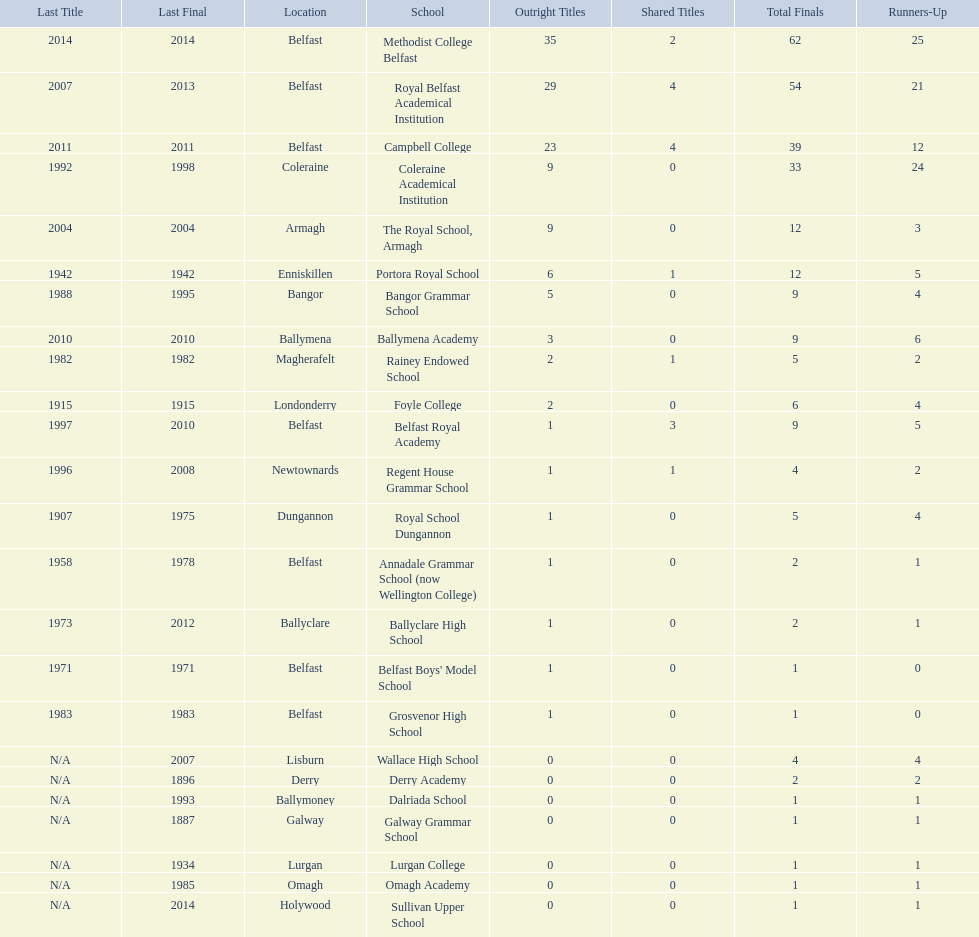What were all of the school names? Methodist College Belfast, Royal Belfast Academical Institution, Campbell College, Coleraine Academical Institution, The Royal School, Armagh, Portora Royal School, Bangor Grammar School, Ballymena Academy, Rainey Endowed School, Foyle College, Belfast Royal Academy, Regent House Grammar School, Royal School Dungannon, Annadale Grammar School (now Wellington College), Ballyclare High School, Belfast Boys' Model School, Grosvenor High School, Wallace High School, Derry Academy, Dalriada School, Galway Grammar School, Lurgan College, Omagh Academy, Sullivan Upper School. How many outright titles did they achieve? 35, 29, 23, 9, 9, 6, 5, 3, 2, 2, 1, 1, 1, 1, 1, 1, 1, 0, 0, 0, 0, 0, 0, 0. And how many did coleraine academical institution receive? 9. Which other school had the same number of outright titles? The Royal School, Armagh. 